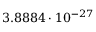<formula> <loc_0><loc_0><loc_500><loc_500>3 . 8 8 8 4 \cdot 1 0 ^ { - 2 7 }</formula> 